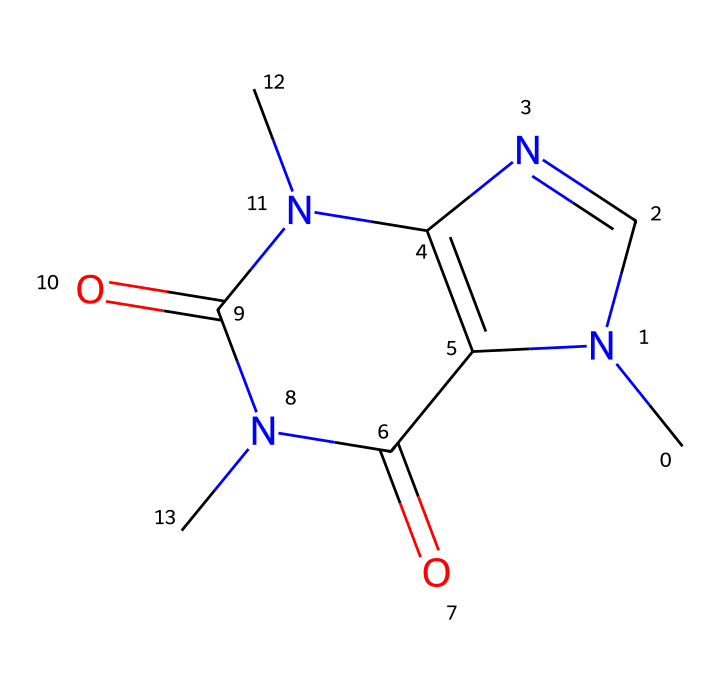What is the molecular formula of caffeine? To determine the molecular formula, we can count the number of carbon (C), hydrogen (H), nitrogen (N), and oxygen (O) atoms present in the SMILES representation. The structure has 8 carbons, 10 hydrogens, 4 nitrogens, and 2 oxygens, resulting in the molecular formula C8H10N4O2.
Answer: C8H10N4O2 How many nitrogen atoms are present in caffeine? By examining the SMILES representation, we identify that there are four distinct nitrogen atoms indicated by the letter 'N'.
Answer: 4 What type of chemical compound is caffeine? Caffeine is classified as an alkaloid, which are naturally occurring compounds that often possess biological activity and contain basic nitrogen atoms. This classification can be inferred from the presence of multiple nitrogen atoms in the structure.
Answer: alkaloid What is the total number of rings in the caffeine structure? In the SMILES representation, there are two fused ring systems that can be identified by the 'N' and 'C' connections and their cyclic nature. Thus, caffeine has two rings.
Answer: 2 How does caffeine affect alertness? Caffeine acts as a stimulant by blocking adenosine receptors in the brain, which prevents drowsiness and increases alertness. This effect can be deduced from its action on neurotransmitter systems.
Answer: increases alertness What is the position of the carbonyl groups in the caffeine structure? The two carbonyl groups (C=O) can be found at specific positions in the cyclic structure, where they contribute to the compound's reactivity and stability. They are located adjacent to the nitrogen atoms.
Answer: adjacent to nitrogen atoms 